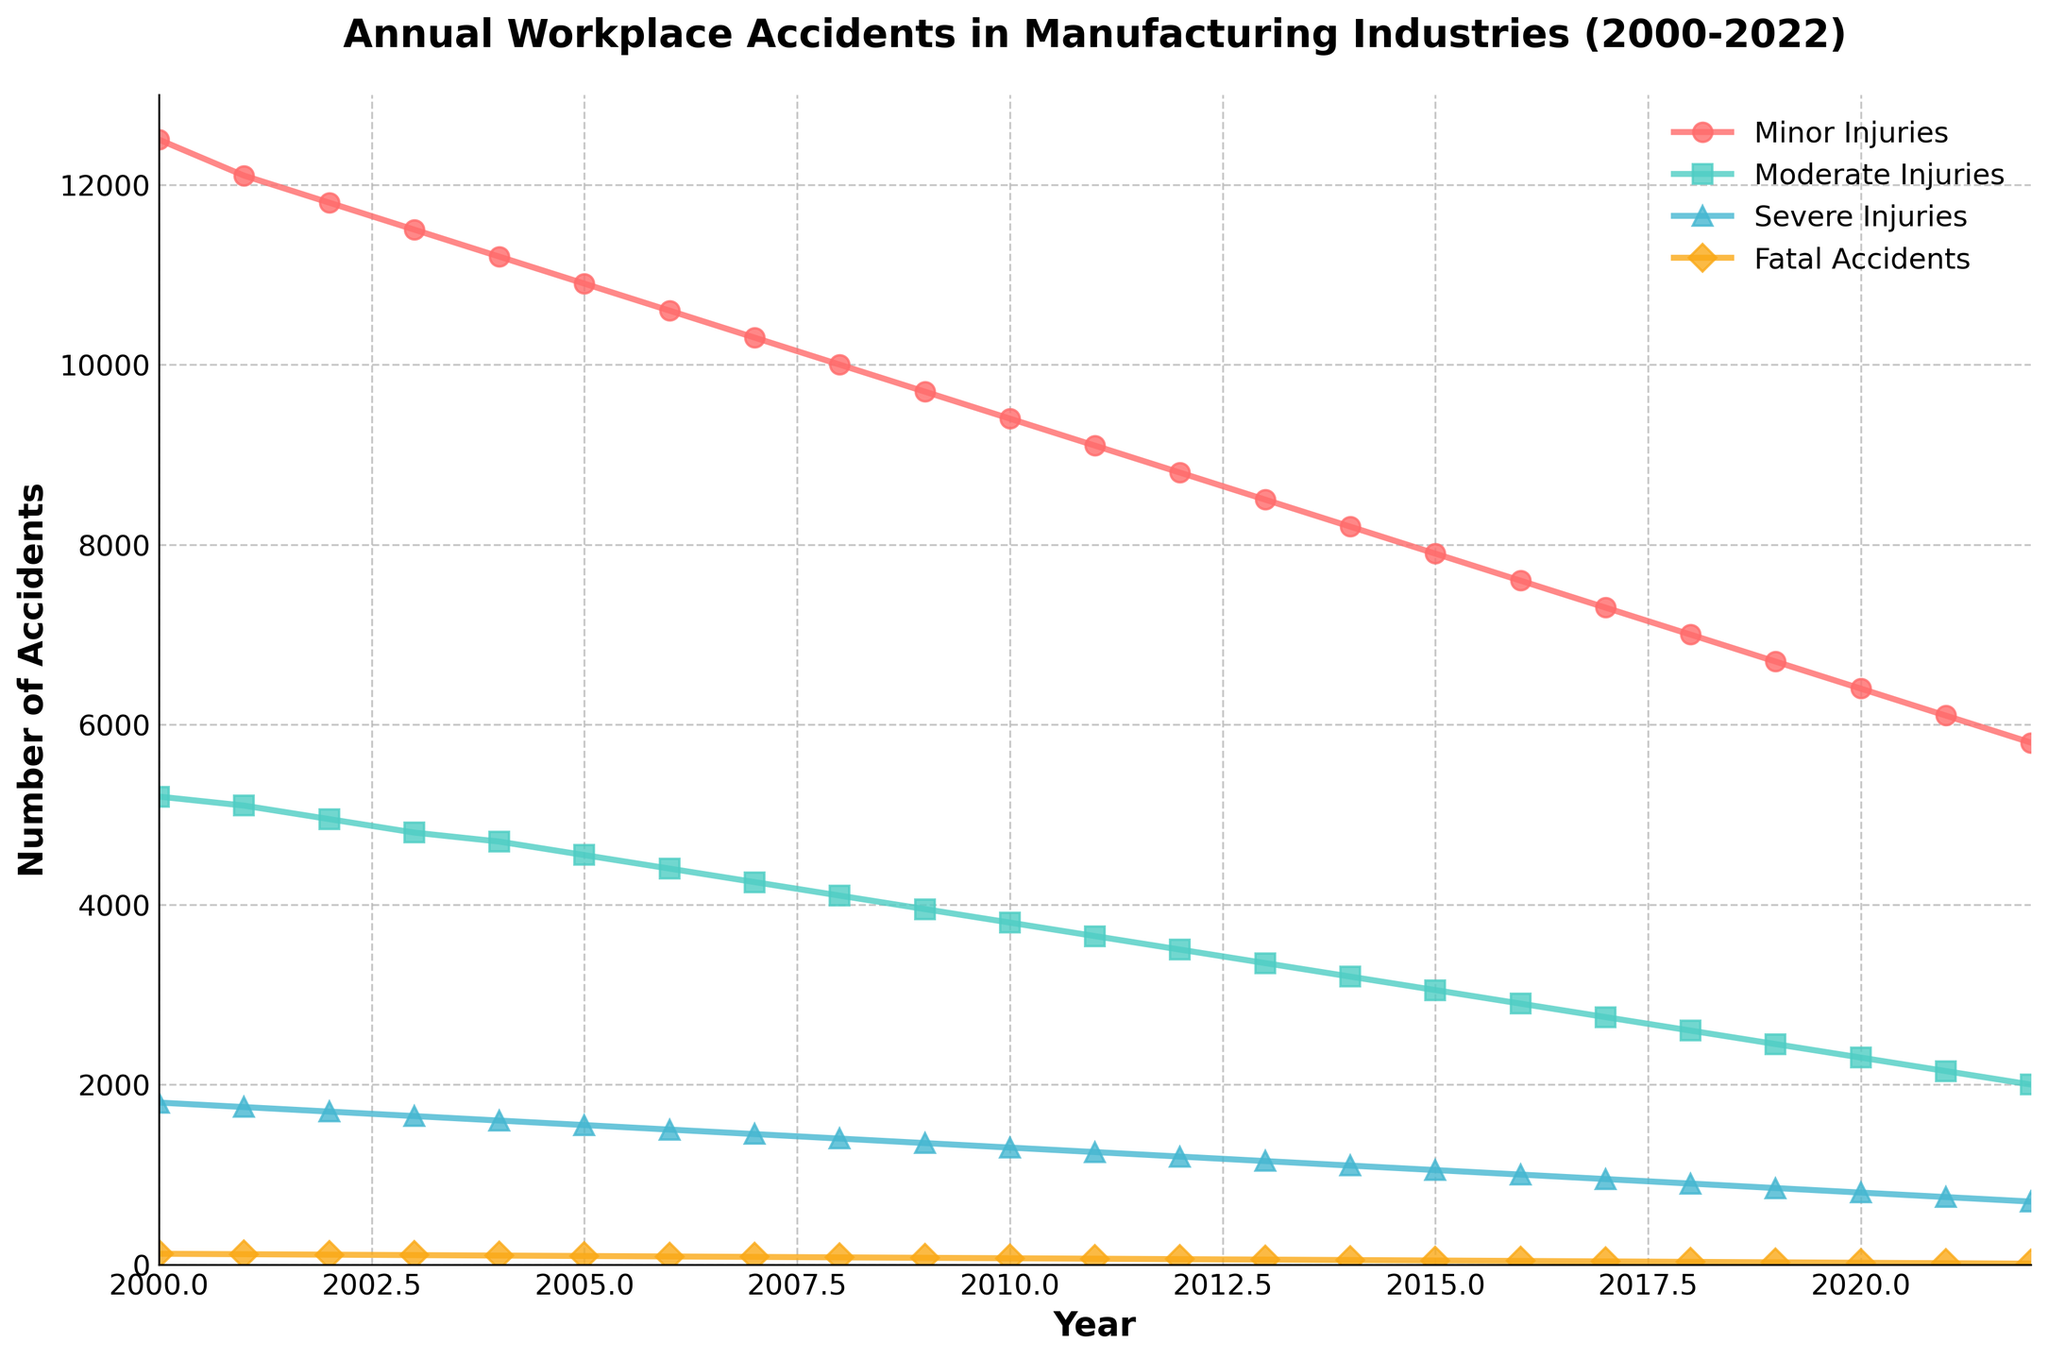What is the total number of minor injuries and moderate injuries in 2010? To find the total number of minor and moderate injuries in 2010, sum the two values. From the chart, minor injuries in 2010 are 9400 and moderate injuries are 3800. Adding them gives 9400 + 3800 = 13200.
Answer: 13200 Which year had the highest number of fatal accidents? Locate the line representing fatal accidents in the chart and find the year at the highest point of this line. The peak of this line is in 2000, with 120 fatal accidents.
Answer: 2000 How many severe injuries were reported in 2015 compared to 2022? Identify the values for severe injuries in 2015 and 2022. From the chart, severe injuries in 2015 were 1050 and in 2022 were 700. The difference is 1050 - 700 = 350.
Answer: 350 What is the trend in minor injuries from 2000 to 2022? Examine the line representing minor injuries from 2000 to 2022. The trend shows a consistent decrease from 12500 in 2000 to 5800 in 2022.
Answer: Decreasing By how much did moderate injuries decrease from 2010 to 2022? To find the decrease, subtract the number of moderate injuries in 2022 from those in 2010. In 2010, moderate injuries were 3800, and in 2022, they were 2000. The decrease is 3800 - 2000 = 1800.
Answer: 1800 In which year did severe injuries drop below 1000 for the first time? Trace the line for severe injuries and find the first year where the value drops below 1000. The first instance is in 2016 when severe injuries were 1000, and in 2017 it becomes 950.
Answer: 2017 What is the overall trend for fatal accidents from 2000 to 2022? Observe the line for fatal accidents from 2000 to 2022. The trend shows a consistent decrease from 120 in 2000 to 10 in 2022.
Answer: Decreasing Between which consecutive years was the largest decrease in the number of minor injuries observed? Compare the year-to-year changes in minor injuries. The largest decrease occurred between 2021 (6100) and 2022 (5800), a reduction of 300 injuries.
Answer: 2021-2022 What is the difference between the peak minor injuries and the lowest minor injuries reported? The peak minor injuries in 2000 are 12500. The lowest minor injuries in 2022 are 5800. The difference is 12500 - 5800 = 6700.
Answer: 6700 Are moderate injuries ever higher than minor injuries in any year from 2000 to 2022? Compare moderate and minor injuries for each year from 2000 to 2022. In all years, minor injuries are higher than moderate injuries.
Answer: No 